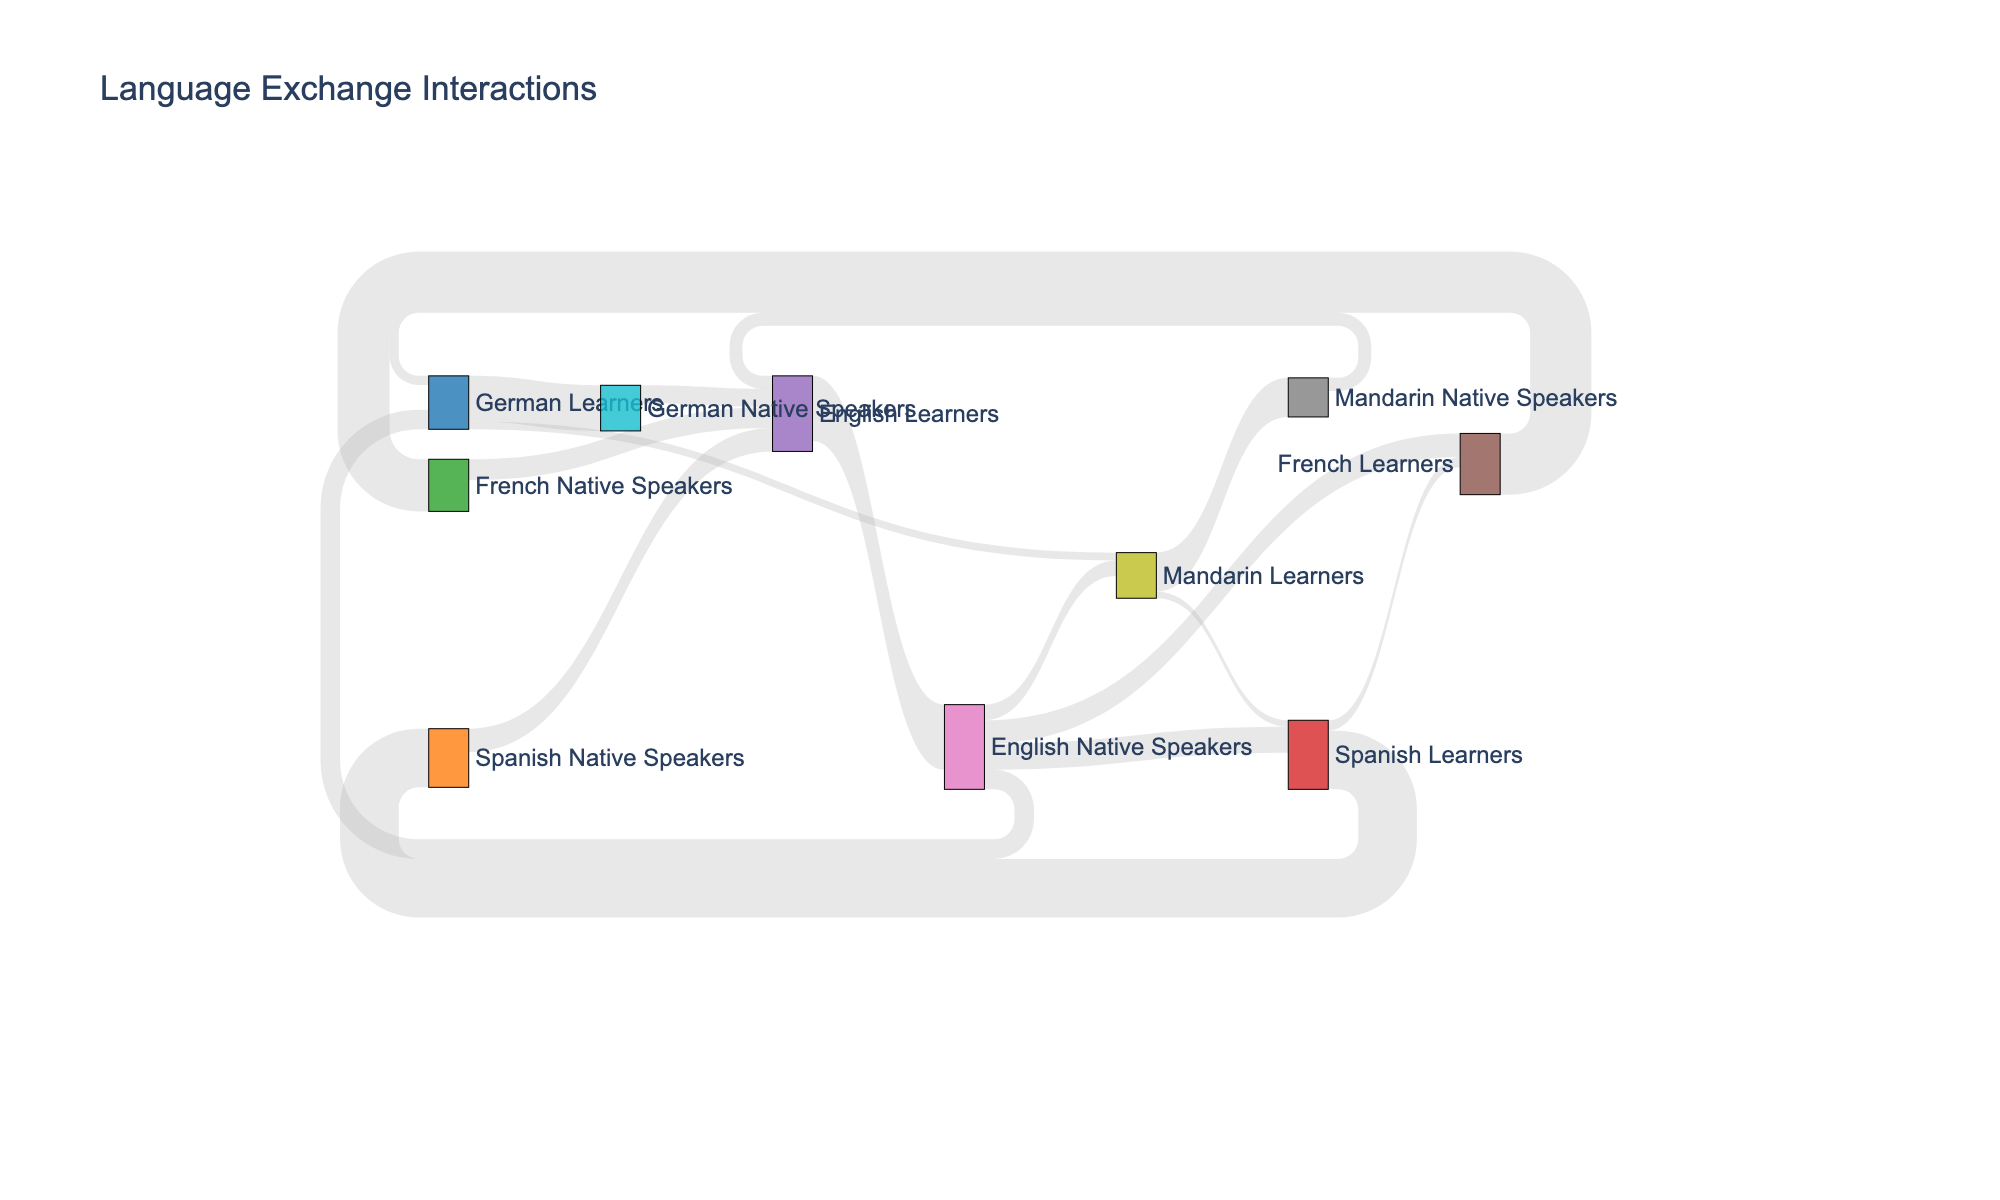How many conversations are there between English Learners and English Native Speakers? The figure shows a link between English Learners and English Native Speakers with a value of 500.
Answer: 500 Which language has the highest number of learners interacting with its native speakers? By examining the flows from learners to native speakers, English Learners interacting with English Native Speakers has the highest value of 500.
Answer: English How many interactions are between Spanish Native Speakers and English Learners? The figure shows a link between Spanish Native Speakers and English Learners with a value of 180.
Answer: 180 What is the total number of interactions involving English Native Speakers? The total interactions involving English Native Speakers can be calculated by summing the values of all their incoming and outgoing links: 500 (from English Learners) + 200 (to Spanish Learners) + 180 (to French Learners) + 150 (to German Learners) + 120 (to Mandarin Learners) = 1150.
Answer: 1150 What is the sum of interactions between French Learners and French Native Speakers, and French Native Speakers and English Learners? The values for these interactions are 400 and 160 respectively. The sum is: 400 + 160 = 560.
Answer: 560 Which group of native speakers has the least number of interactions with English Learners? Reviewing the interactions incoming to English Learners, the smallest value is the interaction from Mandarin Native Speakers with a value of 100.
Answer: Mandarin Native Speakers Are there more interactions between Spanish Learners and Spanish Native Speakers or between German Learners and German Native Speakers? The figure shows interactions between Spanish Learners and Spanish Native Speakers as 450, and between German Learners and German Native Speakers as 350. 450 is greater than 350.
Answer: Spanish Learners and Spanish Native Speakers What is the total number of interactions involving Mandarin Native Speakers? The total interactions for Mandarin Native Speakers can be calculated by summing their incoming and outgoing interactions: 300 (from Mandarin Learners) + 100 (to English Learners) = 400.
Answer: 400 